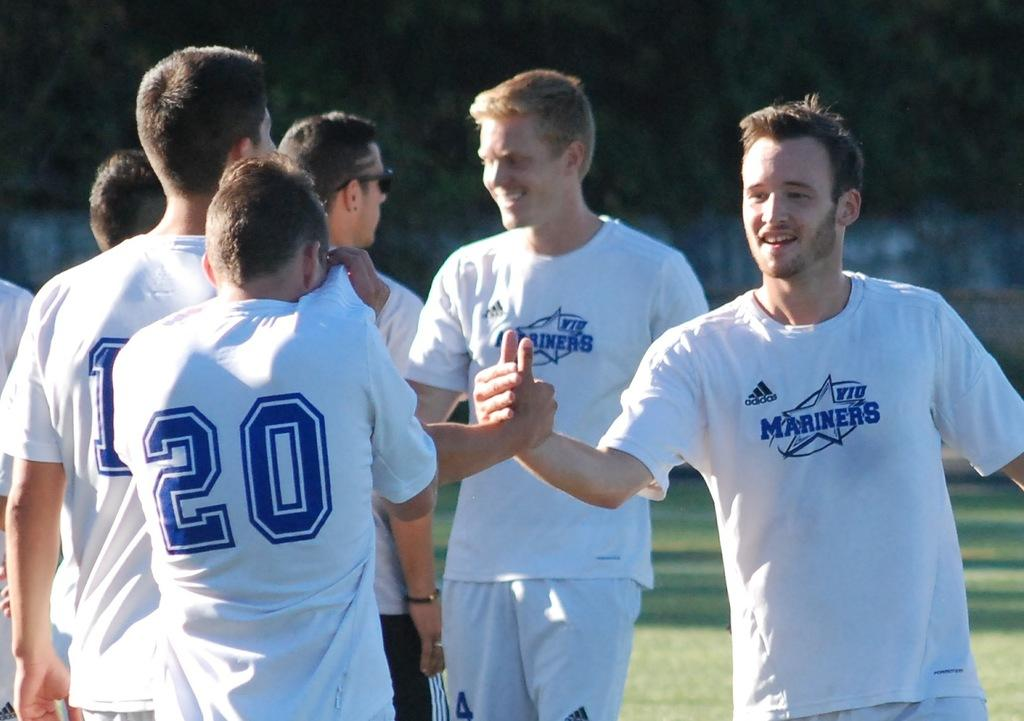Provide a one-sentence caption for the provided image. The men of the Mariners are congratulating each other with handshakes. 